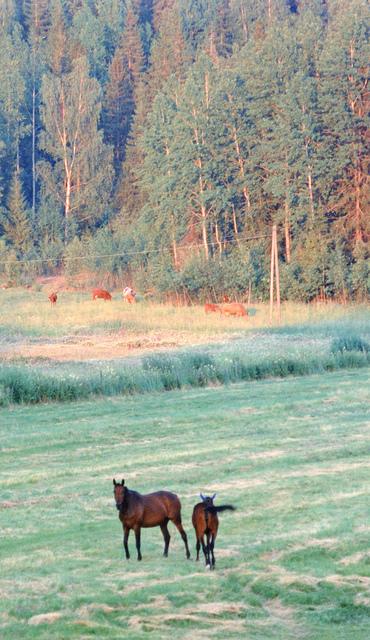Are these wild horses?
Be succinct. No. How many horses are there?
Write a very short answer. 2. Is it a sunny day?
Quick response, please. Yes. 